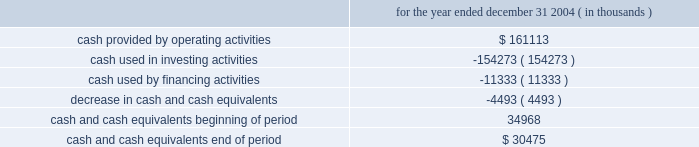The internal revenue code .
Therefore , cash needed to execute our strategy and invest in new properties , as well as to pay our debt at maturity , must come from one or more of the following sources : 2022 cash not distributed to shareholders , 2022 proceeds of property dispositions , or 2022 proceeds derived from the issuance of new debt or equity securities .
It is management 2019s intention that we continually have access to the capital resources necessary to expand and develop our business .
As a result , we intend to operate with and maintain a conservative capital structure that will allow us to maintain strong debt service coverage and fixed-charge coverage ratios as part of our commitment to investment-grade debt ratings .
We may , from time to time , seek to obtain funds by the following means : 2022 additional equity offerings , 2022 unsecured debt financing and/or mortgage financings , and 2022 other debt and equity alternatives , including formation of joint ventures , in a manner consistent with our intention to operate with a conservative debt structure .
Cash and cash equivalents were $ 30.5 million and $ 35.0 million at december 31 , 2004 and december 31 , 2003 , respectively .
Summary of cash flows for the year ended december 31 , 2004 ( in thousands ) .
The cash provided by operating activities is primarily attributable to the operation of our properties and the change in working capital related to our operations .
We used cash of $ 154.3 million during the twelve months ended december 31 , 2004 in investing activities , including the following : 2022 $ 101.7 million for our acquisition of westgate mall , shaw 2019s plaza and several parcels of land , 2022 capital expenditures of $ 59.2 million for development and redevelopment of properties including santana row , 2022 maintenance capital expenditures of approximately $ 36.9 million , 2022 $ 9.4 million capital contribution to a real estate partnership , and 2022 an additional $ 3.2 million net advance under an existing mortgage note receivable ; offset by 2022 $ 41.8 million in net sale proceeds from the sale of properties , and .
What are the percentage of the acquisition of westgate mall , shaw 2019s plaza , and several parcels of land in the investing activities?\\n? 
Rationale: it is the value of that acquisition divided by the total investing activities value , then turned into a percentage .
Computations: (101.7 / 154.3)
Answer: 0.65911. 